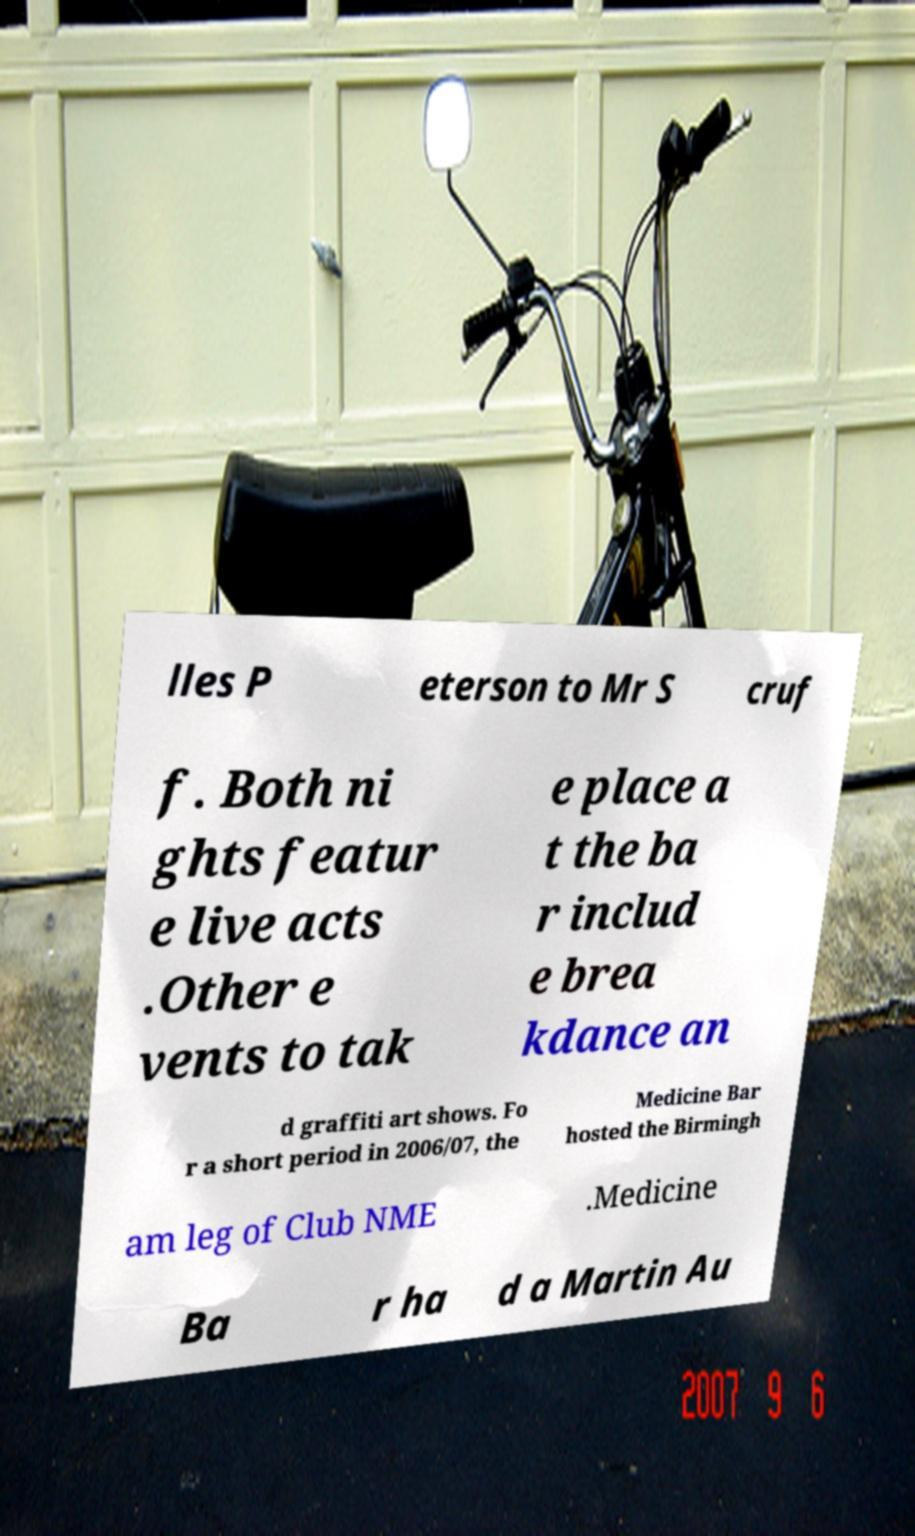I need the written content from this picture converted into text. Can you do that? lles P eterson to Mr S cruf f. Both ni ghts featur e live acts .Other e vents to tak e place a t the ba r includ e brea kdance an d graffiti art shows. Fo r a short period in 2006/07, the Medicine Bar hosted the Birmingh am leg of Club NME .Medicine Ba r ha d a Martin Au 